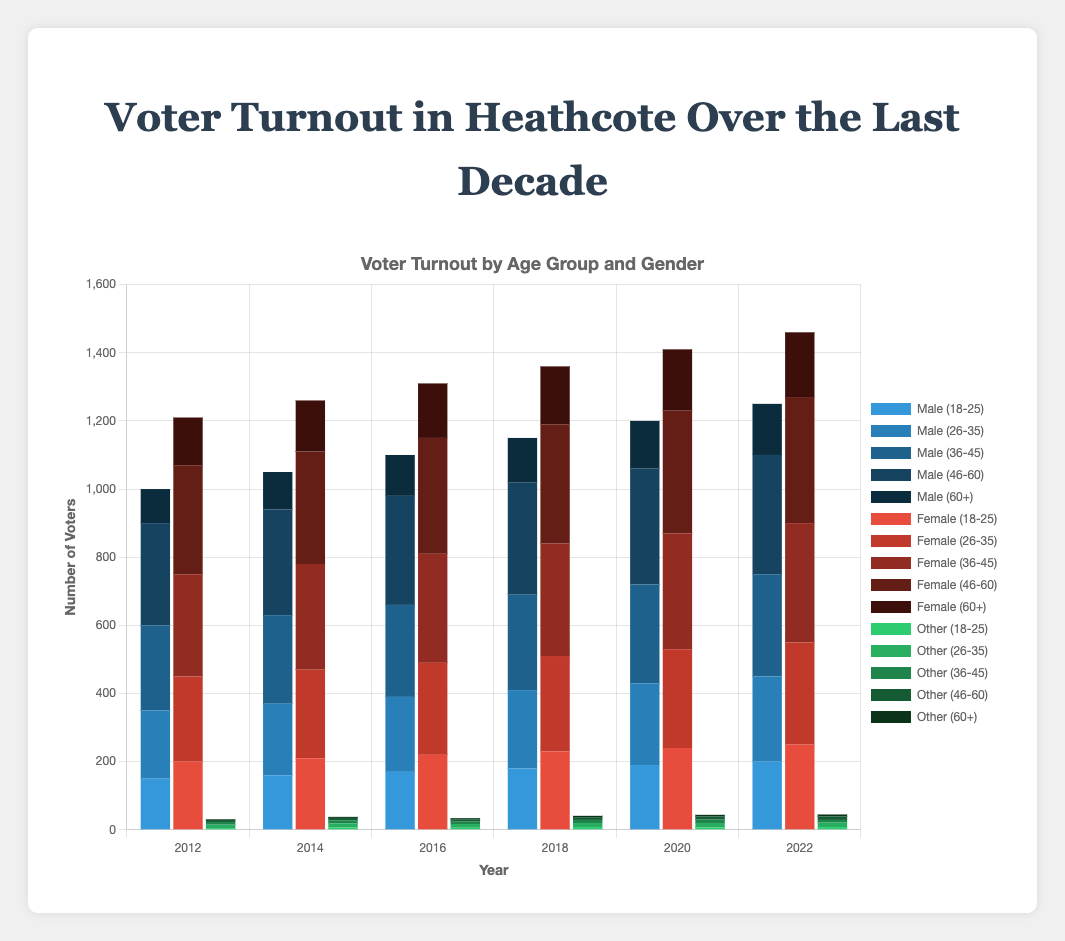What is the total number of voters in 2022 for the age group 18-25? To find the total number of voters in 2022 for the age group 18-25, add the number of male, female, and other voters: 200 (Male) + 250 (Female) + 8 (Other) = 458
Answer: 458 How did the voter turnout for males aged 36-45 change between 2012 and 2022? In 2012, the number of males aged 36-45 was 250. In 2022, it was 300. The difference is 300 - 250 = 50. The voter turnout for males aged 36-45 increased by 50.
Answer: Increased by 50 Which gender had the highest voter turnout in 2020? To find the gender with the highest turnout, add the voter counts for all age groups within each gender and compare: Male (190+240+290+340+140), Female (240+290+340+360+180), Other (7+13+10+9+5). The totals are 1,200 (Male), 1,410 (Female), 44 (Other). Therefore, females had the highest turnout.
Answer: Female What is the percentage increase in the number of female voters aged 46-60 from 2012 to 2022? In 2012, the number of female voters aged 46-60 was 320. In 2022, it was 370. The increase is 370 - 320 = 50. The percentage increase is (50/320) * 100 ≈ 15.625%
Answer: 15.625% Compare the voter turnout growth between the age groups 26-35 and 60+ from 2012 to 2022. For the 26-35 age group: In 2012, the total was 200 (Male) + 250 (Female) + 10 (Other) = 460. In 2022, it was 250 (Male) + 300 (Female) + 13 (Other) = 563. The growth is 563 - 460 = 103. For the 60+ age group: In 2012, the total was 100 (Male) + 140 (Female) + 2 (Other) = 242. In 2022, it was 150 (Male) + 190 (Female) + 6 (Other) = 346. The growth is 346 - 242 = 104. Both age groups showed similar growth (103 vs. 104).
Answer: Similar growth Which age group had the most significant increase in voter turnout from 2018 to 2020? Calculate the increase for each age group: 
18-25: (190+240+7) - (180+230+8) = 437 - 418 = 19
26-35: (240+290+13) - (230+280+12) = 543 - 522 = 21
36-45: (290+340+10) - (280+330+9) = 640 - 619 = 21
46-60: (340+360+9) - (330+350+8) = 709 - 688 = 21
60+: (140+180+5) - (130+170+4) = 325 - 304 = 21. All the age groups had an increase of 21, except 18-25, which was 19.
Answer: 26-60 (Other than 18-25) How many "Other" gender voters participated in 2014 across all age groups? Add the number of "Other" gender voters for each age group in 2014: 7 (18-25) + 12 (26-35) + 9 (36-45) + 7 (46-60) + 3 (60+) = 38
Answer: 38 What is the ratio of female voters to male voters in the 46-60 age group for the year 2016? In 2016, the number of female voters aged 46-60 was 340 and the number of male voters was 320. The ratio is 340:320, which simplifies to 17:16.
Answer: 17:16 Identify the year with the lowest voter turnout for the age group 60+. Sum the voter counts (male, female, other) for the 60+ age group across all years. 2012: 100+140+2=242. 2014: 110+150+3=263. 2016: 120+160+3=283. 2018: 130+170+4=304. 2020: 140+180+5=325. 2022: 150+190+6=346. The lowest turnout is in 2012.
Answer: 2012 How does the 2022 female turnout for the age group 26-35 compare to that of the male turnout for the same year and age group? In 2022, the number of female voters aged 26-35 is 300 and the number of male voters is 250. Therefore, the female turnout is higher by 300 - 250 = 50.
Answer: Female turnout is higher by 50 